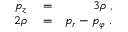<formula> <loc_0><loc_0><loc_500><loc_500>\begin{array} { r l r } { p _ { z } } & = } & { 3 \rho \, , } \\ { 2 \rho } & = } & { p _ { r } - p _ { \varphi } \, . } \end{array}</formula> 